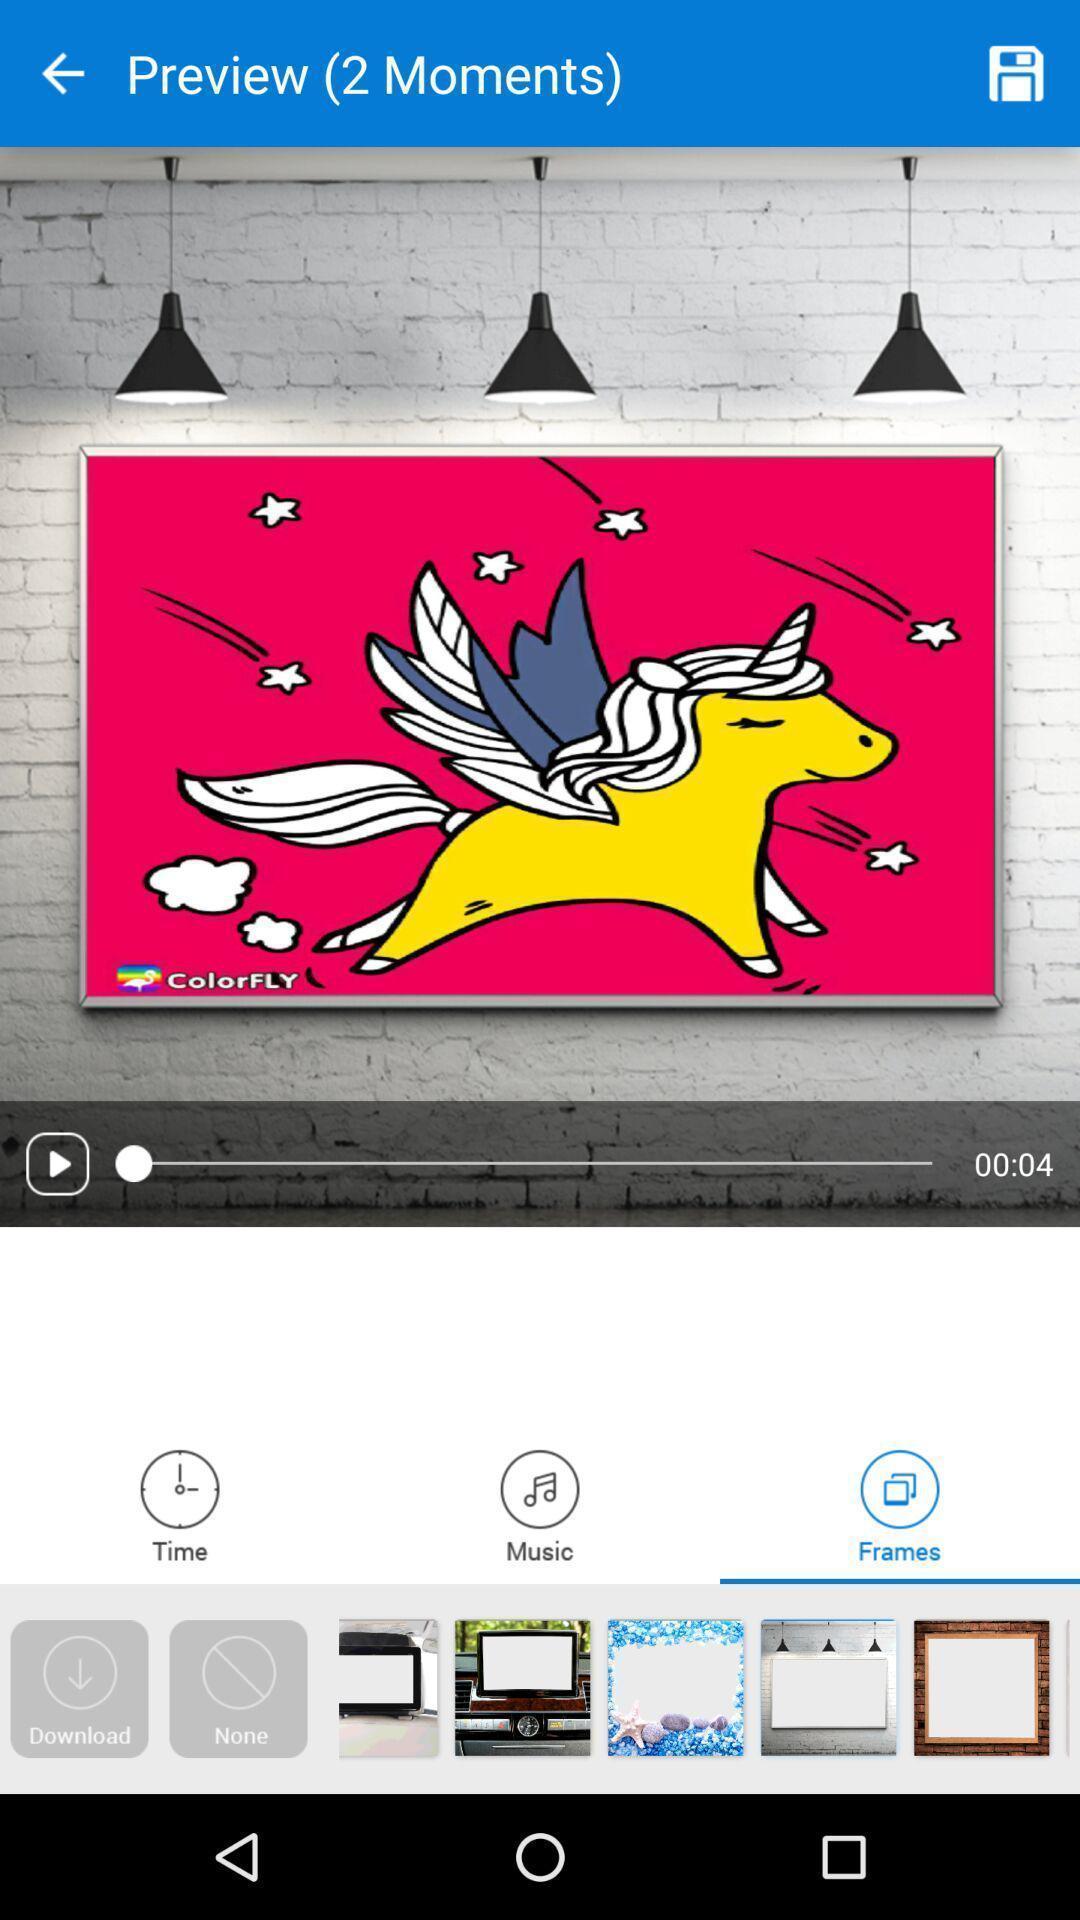Summarize the main components in this picture. Page showing preview moments of a video. 